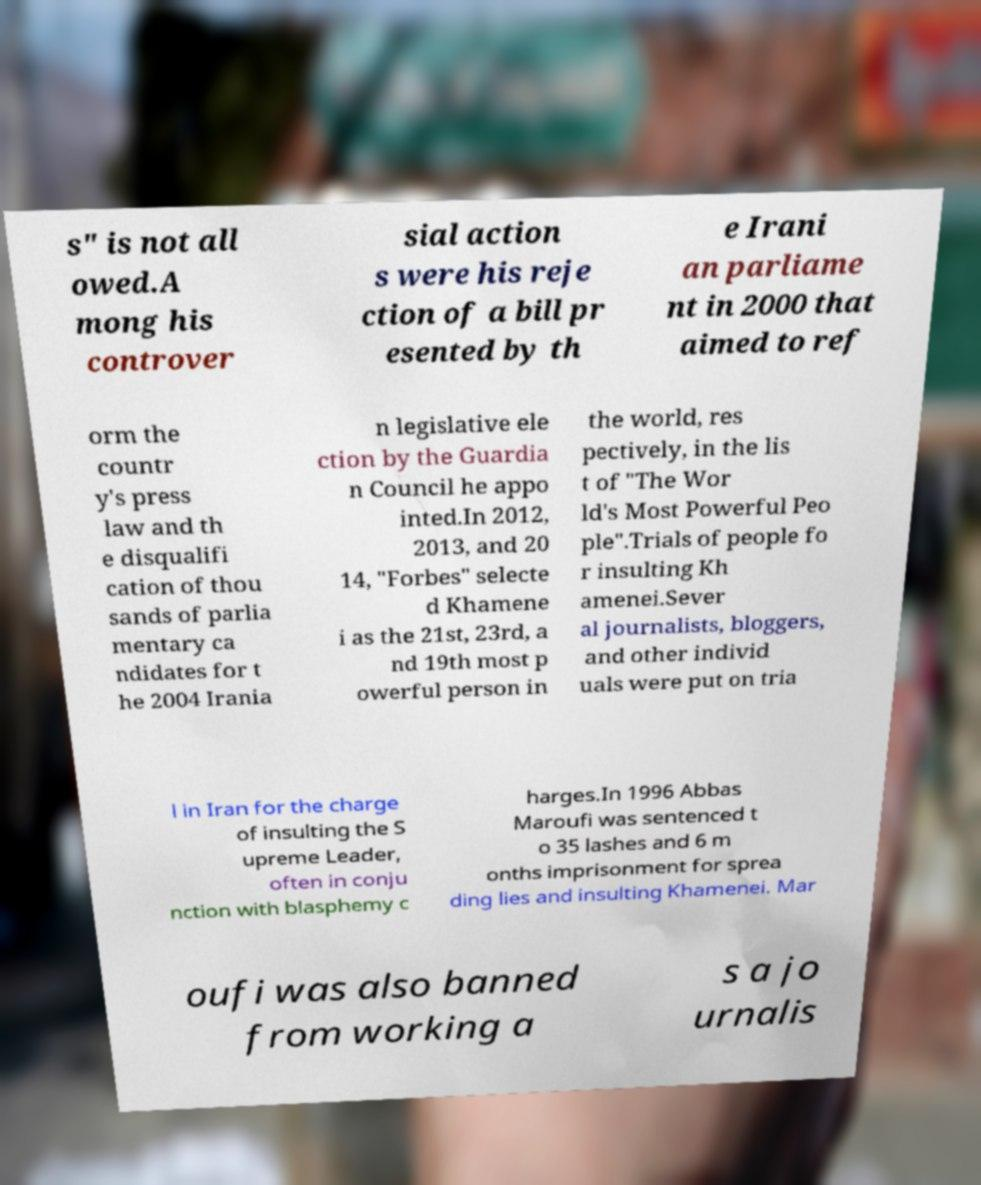There's text embedded in this image that I need extracted. Can you transcribe it verbatim? s" is not all owed.A mong his controver sial action s were his reje ction of a bill pr esented by th e Irani an parliame nt in 2000 that aimed to ref orm the countr y's press law and th e disqualifi cation of thou sands of parlia mentary ca ndidates for t he 2004 Irania n legislative ele ction by the Guardia n Council he appo inted.In 2012, 2013, and 20 14, "Forbes" selecte d Khamene i as the 21st, 23rd, a nd 19th most p owerful person in the world, res pectively, in the lis t of "The Wor ld's Most Powerful Peo ple".Trials of people fo r insulting Kh amenei.Sever al journalists, bloggers, and other individ uals were put on tria l in Iran for the charge of insulting the S upreme Leader, often in conju nction with blasphemy c harges.In 1996 Abbas Maroufi was sentenced t o 35 lashes and 6 m onths imprisonment for sprea ding lies and insulting Khamenei. Mar oufi was also banned from working a s a jo urnalis 